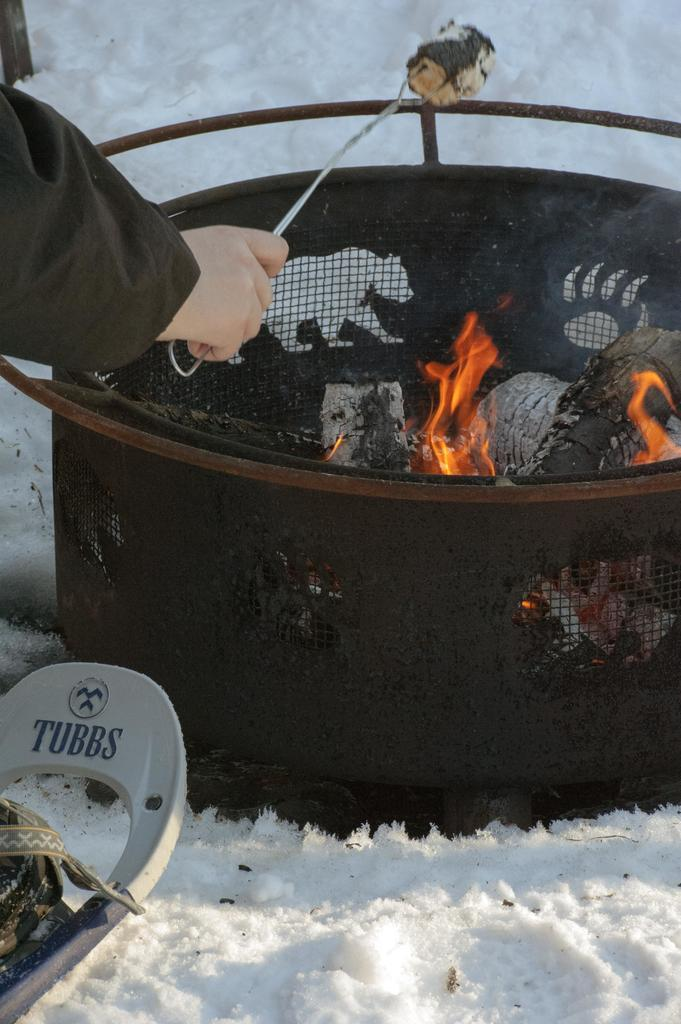What is the person in the image holding? The person is holding a stick in the image. Can you describe the object located in the bottom left of the image? Unfortunately, the provided facts do not give enough information to describe the object in the bottom left of the image. What is the main feature in the middle of the image? There is a fire pit in the middle of the image. What type of floor can be seen in the image? The provided facts do not mention any floor in the image. 